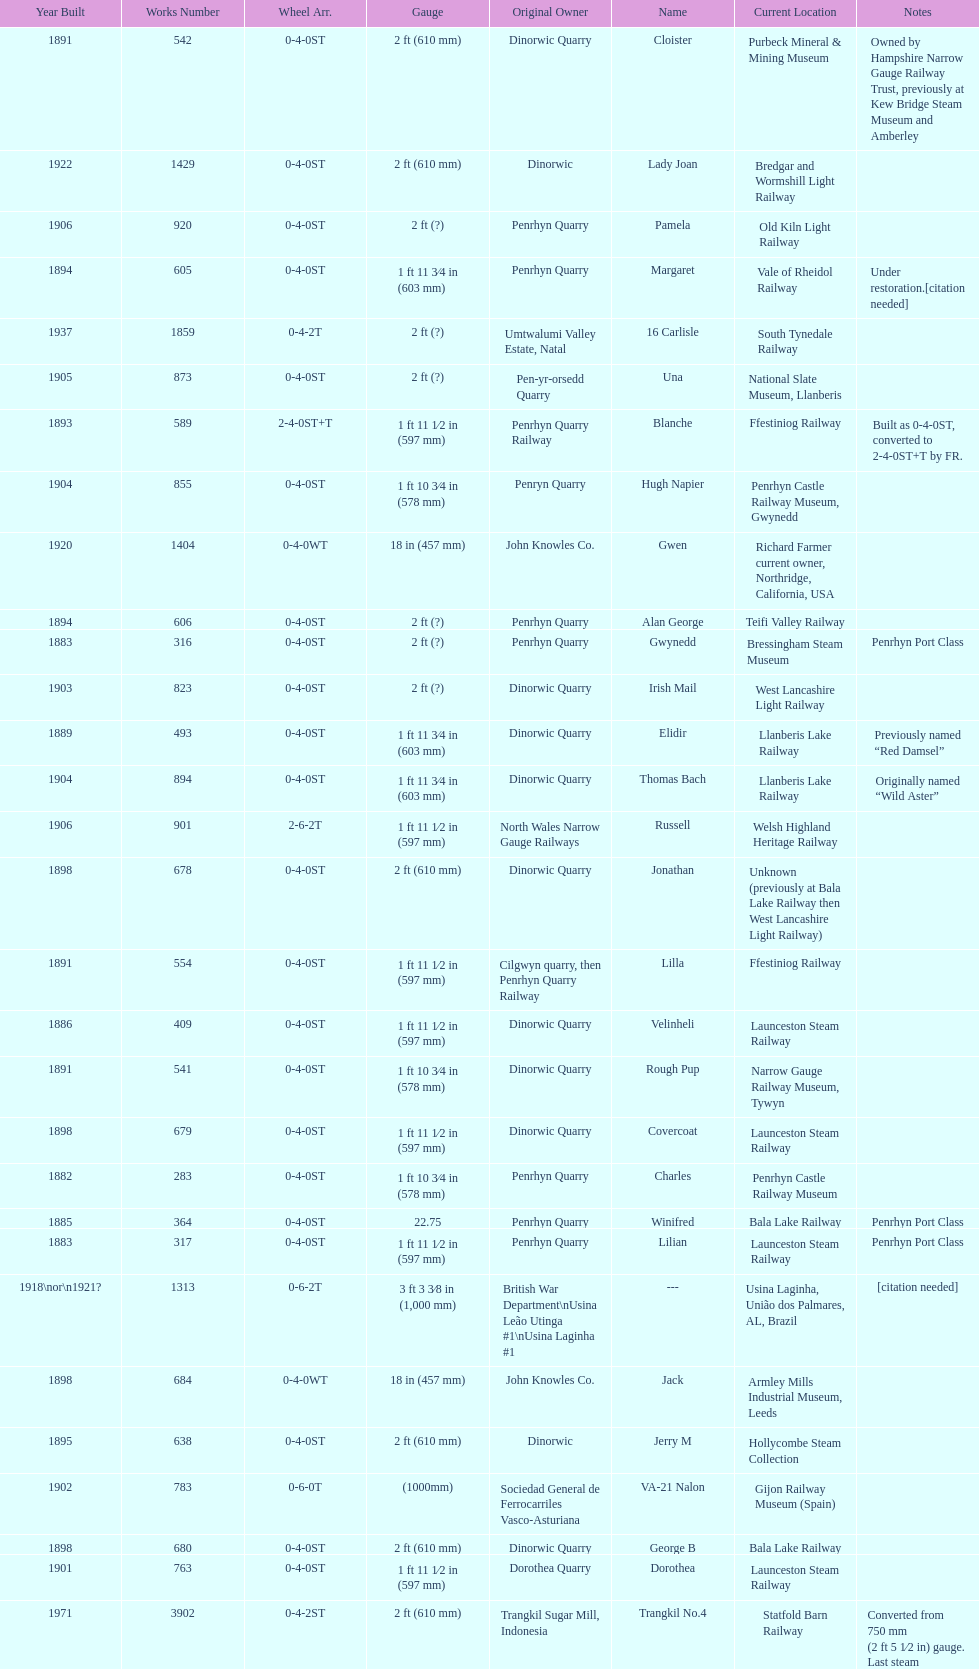How many steam locomotives are currently located at the bala lake railway? 364. 